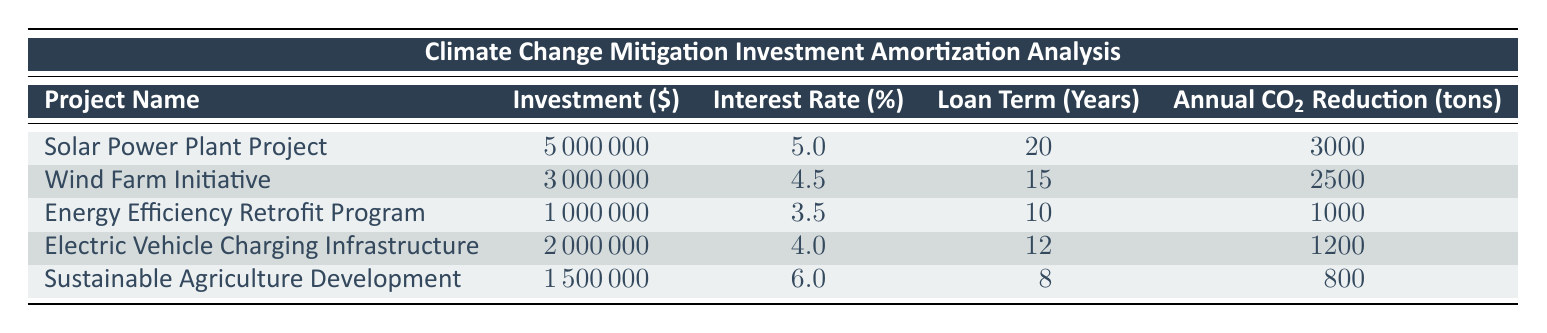What is the total investment amount for all projects listed? To find the total investment amount, sum the investment amounts of all the projects: 5000000 + 3000000 + 1000000 + 2000000 + 1500000 = 13500000.
Answer: 13500000 Which project has the highest annual reduction in carbon emissions? The project with the highest annual reduction in carbon emissions is the Solar Power Plant Project, which reduces 3000 tons of CO2 annually.
Answer: Solar Power Plant Project Is the interest rate for the Wind Farm Initiative higher than 5%? The interest rate for the Wind Farm Initiative is 4.5%, which is lower than 5%. Therefore, the statement is false.
Answer: No What is the average loan term for all projects? To find the average loan term, add all loan terms: (20 + 15 + 10 + 12 + 8) = 65, and divide by the number of projects (5): 65/5 = 13.
Answer: 13 Is there any project that requires less than 1 million in investment? The Energy Efficiency Retrofit Program requires exactly 1000000, which is not less than 1 million; thus, there are no projects requiring less than 1 million.
Answer: No What is the difference in annual CO2 reduction between the Solar Power Plant Project and the Sustainable Agriculture Development project? The annual reduction for the Solar Power Plant Project is 3000 tons and for the Sustainable Agriculture Development is 800 tons. The difference is 3000 - 800 = 2200 tons.
Answer: 2200 Which project has the lowest interest rate, and what is it? The project with the lowest interest rate is the Energy Efficiency Retrofit Program, which has an interest rate of 3.5%.
Answer: Energy Efficiency Retrofit Program, 3.5% What can be inferred about the relationship between investment amounts and annual CO2 reduction? By comparing projects, it is observed that larger investments do not always correspond to higher CO2 reductions on a per dollar basis, as seen with the Energy Efficiency program. Therefore, the relationship is not straightforward.
Answer: Investment amounts do not always correlate with annual CO2 reduction Does the Electric Vehicle Charging Infrastructure have a higher investment than the Sustainable Agriculture Development project? The Electric Vehicle Charging Infrastructure has an investment of 2000000, while the Sustainable Agriculture Development project has an investment of 1500000. Since 2000000 is greater than 1500000, the statement is true.
Answer: Yes 